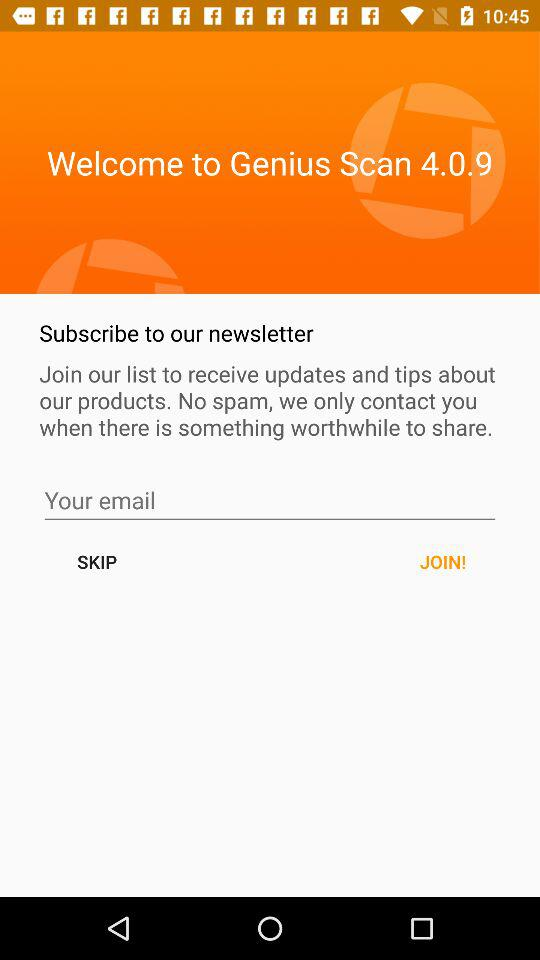What is the entered email address?
When the provided information is insufficient, respond with <no answer>. <no answer> 